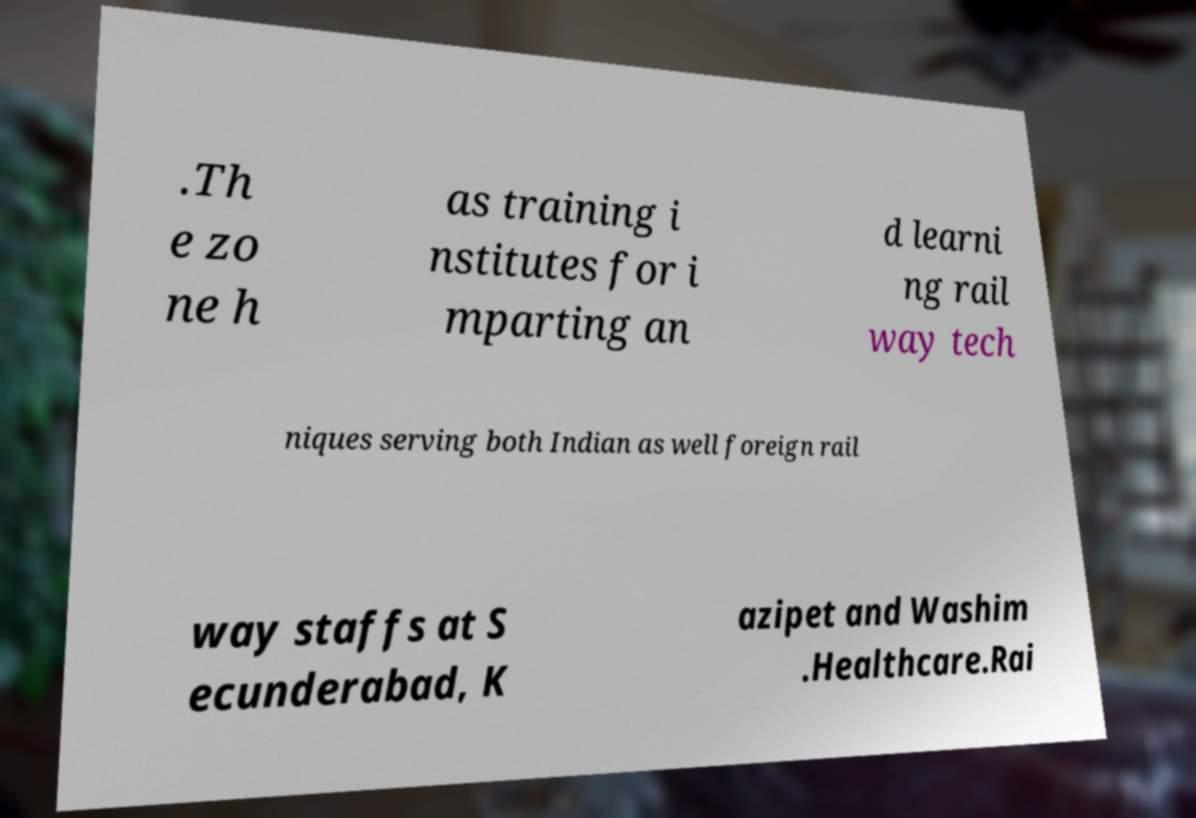Please identify and transcribe the text found in this image. .Th e zo ne h as training i nstitutes for i mparting an d learni ng rail way tech niques serving both Indian as well foreign rail way staffs at S ecunderabad, K azipet and Washim .Healthcare.Rai 